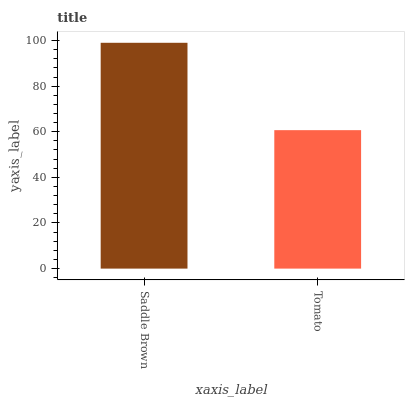Is Tomato the minimum?
Answer yes or no. Yes. Is Saddle Brown the maximum?
Answer yes or no. Yes. Is Tomato the maximum?
Answer yes or no. No. Is Saddle Brown greater than Tomato?
Answer yes or no. Yes. Is Tomato less than Saddle Brown?
Answer yes or no. Yes. Is Tomato greater than Saddle Brown?
Answer yes or no. No. Is Saddle Brown less than Tomato?
Answer yes or no. No. Is Saddle Brown the high median?
Answer yes or no. Yes. Is Tomato the low median?
Answer yes or no. Yes. Is Tomato the high median?
Answer yes or no. No. Is Saddle Brown the low median?
Answer yes or no. No. 